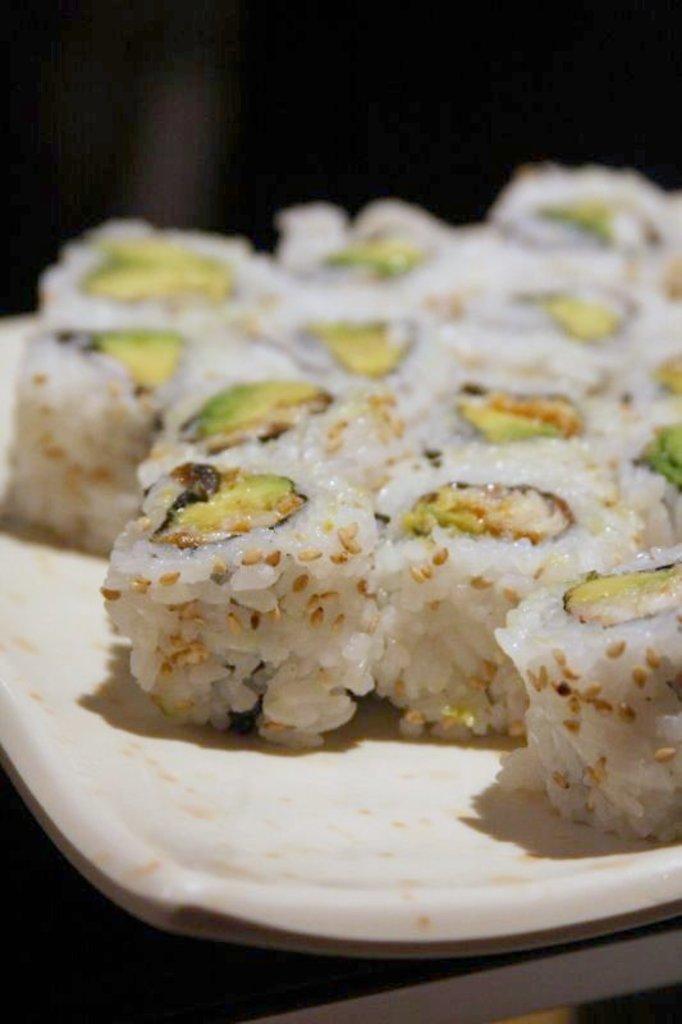In one or two sentences, can you explain what this image depicts? In the image I can see a plate in which there is some food item. 